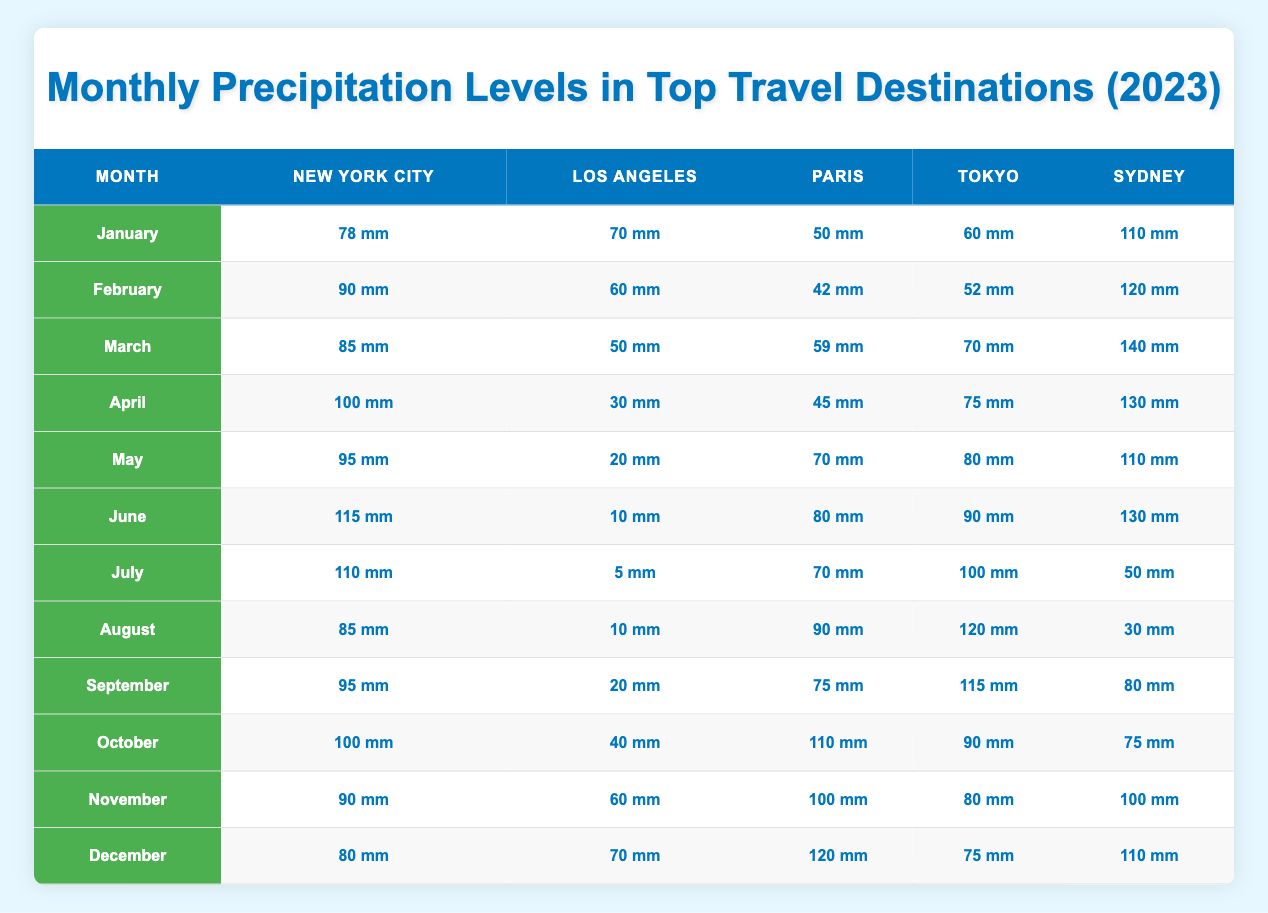What is the total precipitation for Sydney in March? In March, Sydney received 140 mm of precipitation. This can be found directly in the table under the March row and Sydney column.
Answer: 140 mm Which month had the least precipitation in Los Angeles? Inspecting the table, in July, Los Angeles had only 5 mm of precipitation, which is less than any other month. This value is seen in the July row and Los Angeles column.
Answer: 5 mm Was the average precipitation in New York City higher or lower than 90 mm throughout the year? To find the average, sum the monthly precipitation levels for New York City: (78 + 90 + 85 + 100 + 95 + 115 + 110 + 85 + 95 + 100 + 90 + 80) = 1150 mm. There are 12 months, so the average is 1150/12 = approximately 95.83 mm, which is higher than 90 mm.
Answer: Higher How much more precipitation did Paris receive in December compared to June? In December, Paris had 120 mm and in June, it had 80 mm. Subtracting these values gives 120 - 80 = 40 mm, indicating the difference in precipitation between these two months for Paris.
Answer: 40 mm In which month did Tokyo receive the most precipitation, and how much was it? Checking the table, Tokyo received 115 mm of precipitation in September, which is the highest in all months compared to other values listed for Tokyo.
Answer: September, 115 mm Did Sydney receive more precipitation in February than in October? In February, Sydney had 120 mm of precipitation, while in October, it had 75 mm. Since 120 mm is greater than 75 mm, the answer is yes.
Answer: Yes What is the combined precipitation for New York City and Paris in April? In April, New York City had 100 mm and Paris had 45 mm. Adding these together gives us 100 + 45 = 145 mm as the total for that month.
Answer: 145 mm Which city received the most precipitation in the month of June? According to the table, in June, Sydney received 130 mm, which is more than any other city in June. Comparing with other cities: New York City (115 mm), Los Angeles (10 mm), Paris (80 mm), and Tokyo (90 mm) confirms that Sydney had the most.
Answer: Sydney, 130 mm What was the precipitation trend for Los Angeles over the first half of the year? Referring to the table from January to June, Los Angeles had 70 mm, 60 mm, 50 mm, 30 mm, 20 mm, and 10 mm respectively. This shows a downward trend as the amounts decrease each month, indicating that Los Angeles experienced less rainfall as the year progressed.
Answer: Decreasing trend 